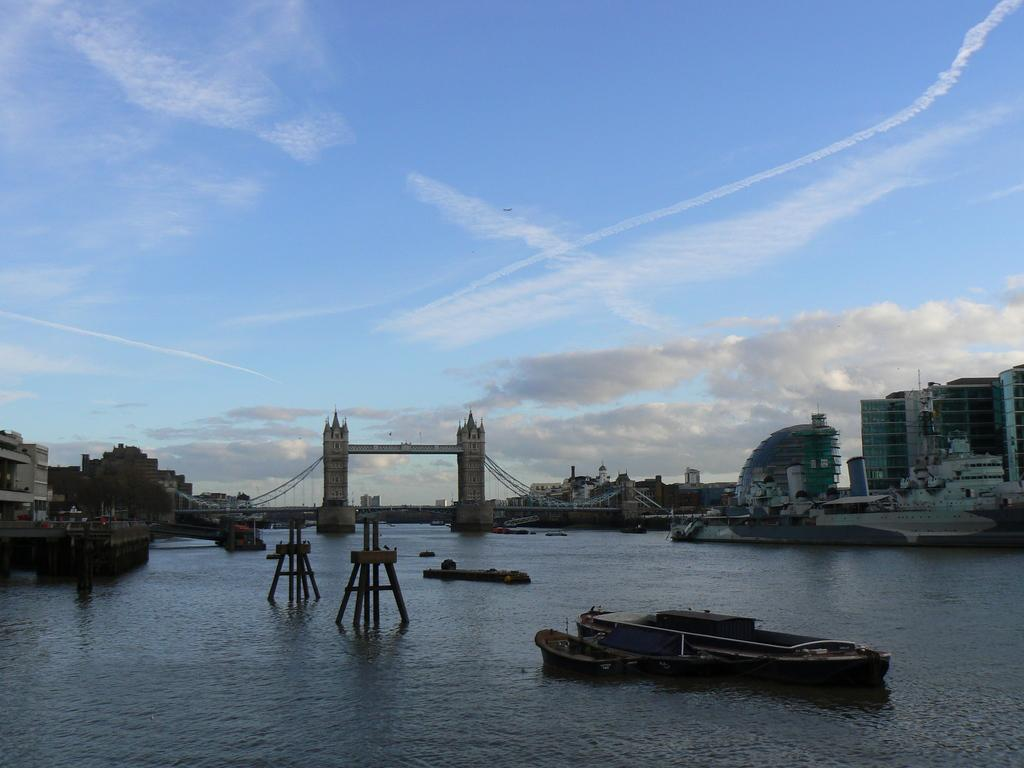What is located in the foreground of the image? There are boats in the foreground of the image. What is the boats' location in relation to the image? The boats are on the water. What can be seen in the background of the image? There are buildings, a bridge, and the sky visible in the background of the image. What is the condition of the sky in the image? The sky is visible in the background of the image, and there are clouds present. What type of knife is being used by the person on the bridge in the image? There is no person or knife present on the bridge in the image. What language is being spoken by the people in the boats in the image? There is no indication of any spoken language in the image, as it only shows boats on the water and buildings in the background. 